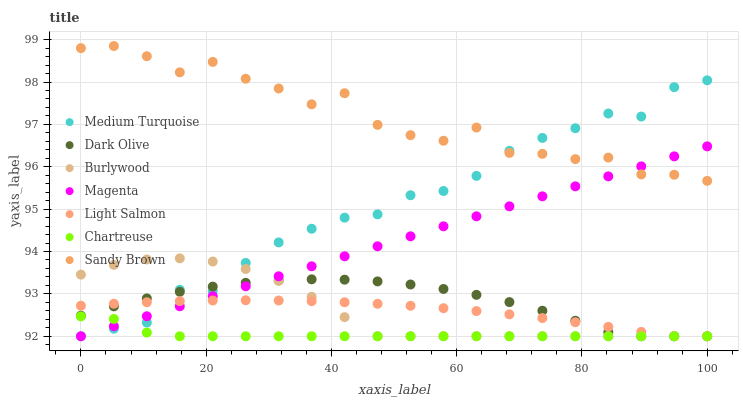Does Chartreuse have the minimum area under the curve?
Answer yes or no. Yes. Does Sandy Brown have the maximum area under the curve?
Answer yes or no. Yes. Does Burlywood have the minimum area under the curve?
Answer yes or no. No. Does Burlywood have the maximum area under the curve?
Answer yes or no. No. Is Magenta the smoothest?
Answer yes or no. Yes. Is Sandy Brown the roughest?
Answer yes or no. Yes. Is Burlywood the smoothest?
Answer yes or no. No. Is Burlywood the roughest?
Answer yes or no. No. Does Light Salmon have the lowest value?
Answer yes or no. Yes. Does Sandy Brown have the lowest value?
Answer yes or no. No. Does Sandy Brown have the highest value?
Answer yes or no. Yes. Does Burlywood have the highest value?
Answer yes or no. No. Is Dark Olive less than Sandy Brown?
Answer yes or no. Yes. Is Sandy Brown greater than Dark Olive?
Answer yes or no. Yes. Does Medium Turquoise intersect Sandy Brown?
Answer yes or no. Yes. Is Medium Turquoise less than Sandy Brown?
Answer yes or no. No. Is Medium Turquoise greater than Sandy Brown?
Answer yes or no. No. Does Dark Olive intersect Sandy Brown?
Answer yes or no. No. 